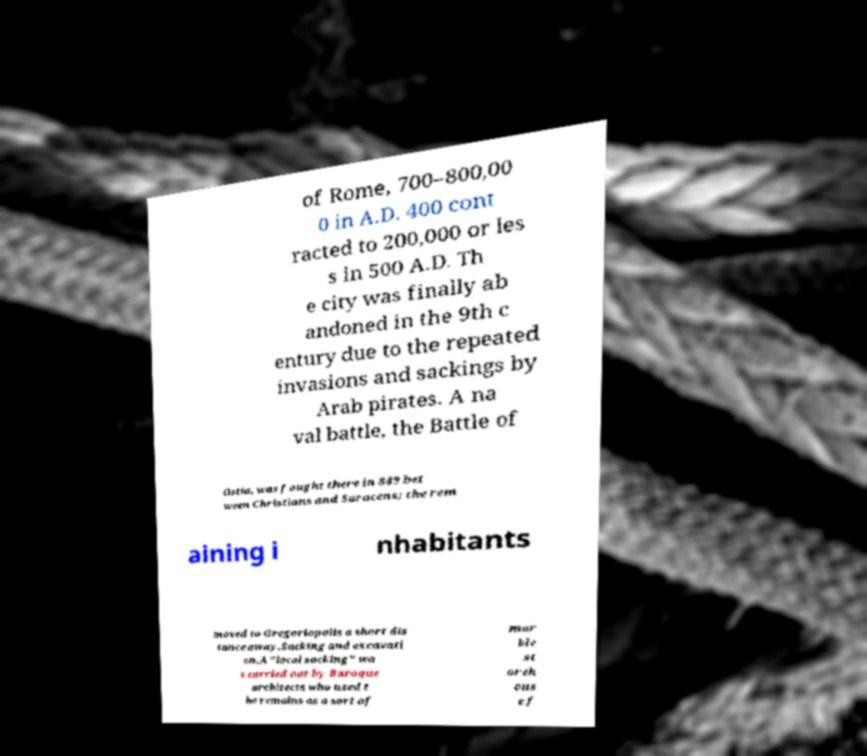Can you accurately transcribe the text from the provided image for me? of Rome, 700–800,00 0 in A.D. 400 cont racted to 200,000 or les s in 500 A.D. Th e city was finally ab andoned in the 9th c entury due to the repeated invasions and sackings by Arab pirates. A na val battle, the Battle of Ostia, was fought there in 849 bet ween Christians and Saracens; the rem aining i nhabitants moved to Gregoriopolis a short dis tance away.Sacking and excavati on.A "local sacking" wa s carried out by Baroque architects who used t he remains as a sort of mar ble st oreh ous e f 